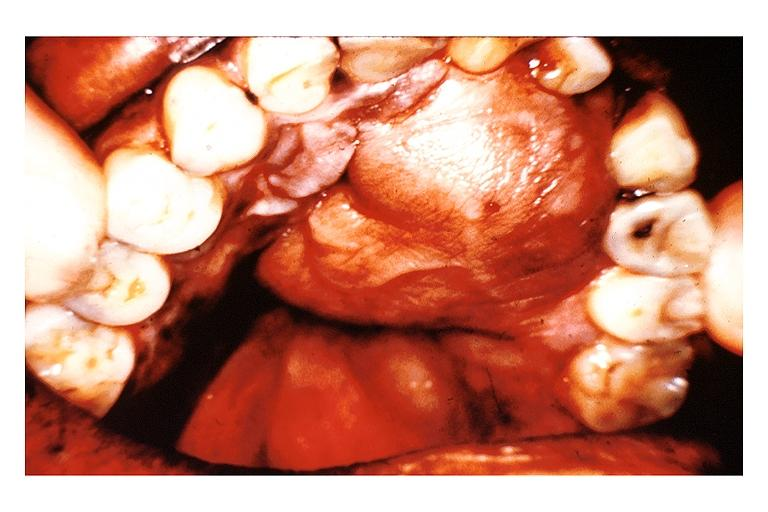where is this?
Answer the question using a single word or phrase. Oral 